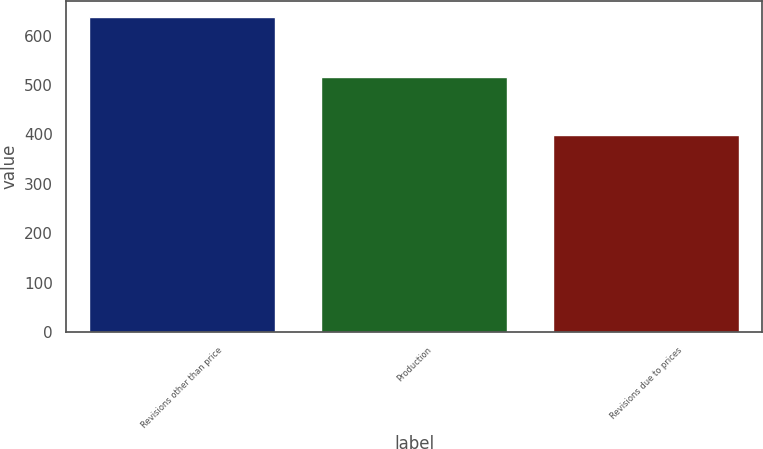<chart> <loc_0><loc_0><loc_500><loc_500><bar_chart><fcel>Revisions other than price<fcel>Production<fcel>Revisions due to prices<nl><fcel>638<fcel>517<fcel>399<nl></chart> 